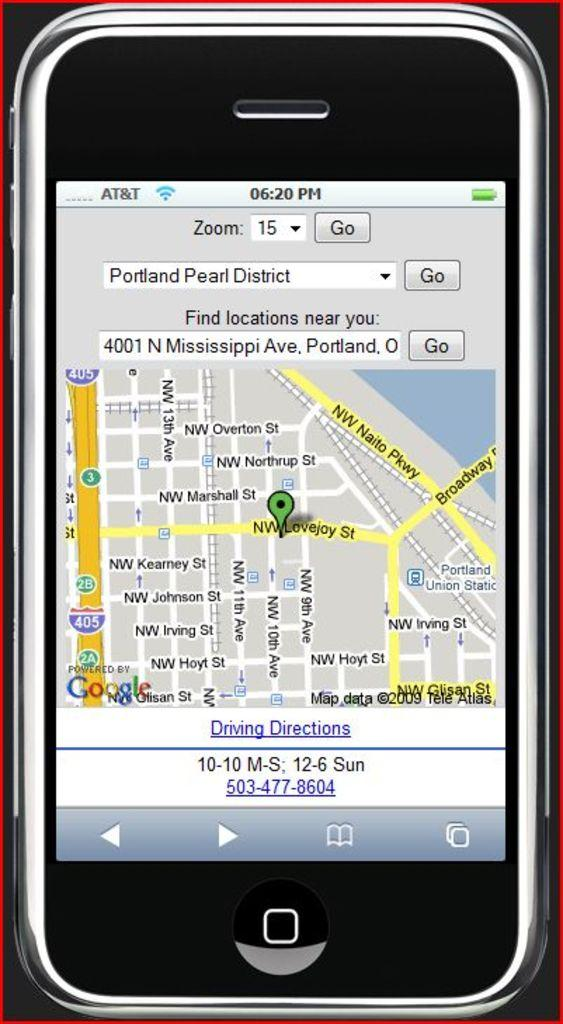<image>
Create a compact narrative representing the image presented. a cell phone with AT&T service shows a map of Portland Pearl District 